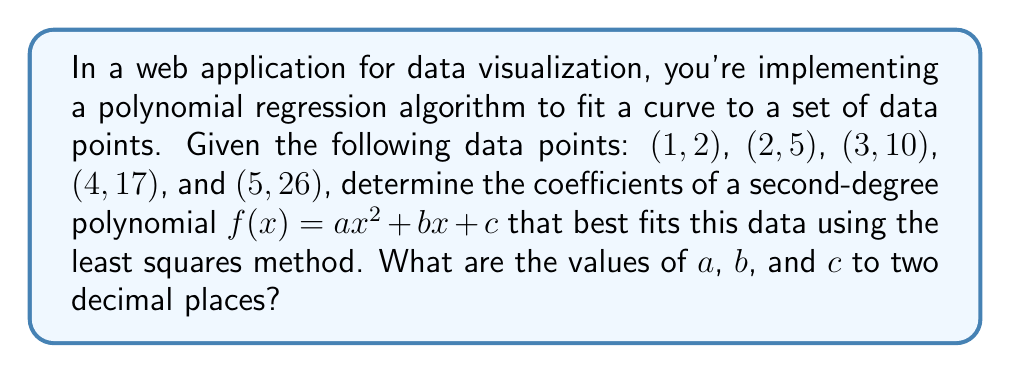Could you help me with this problem? To solve this problem, we'll use the least squares method to find the coefficients of the second-degree polynomial. Here's a step-by-step approach:

1. Set up the system of normal equations:
   $$\begin{aligned}
   \sum y &= an + b\sum x + c\sum x^2 \\
   \sum xy &= a\sum x + b\sum x^2 + c\sum x^3 \\
   \sum x^2y &= a\sum x^2 + b\sum x^3 + c\sum x^4
   \end{aligned}$$

2. Calculate the sums needed for the equations:
   $$\begin{aligned}
   n &= 5 \\
   \sum x &= 1 + 2 + 3 + 4 + 5 = 15 \\
   \sum x^2 &= 1^2 + 2^2 + 3^2 + 4^2 + 5^2 = 55 \\
   \sum x^3 &= 1^3 + 2^3 + 3^3 + 4^3 + 5^3 = 225 \\
   \sum x^4 &= 1^4 + 2^4 + 3^4 + 4^4 + 5^4 = 979 \\
   \sum y &= 2 + 5 + 10 + 17 + 26 = 60 \\
   \sum xy &= 1(2) + 2(5) + 3(10) + 4(17) + 5(26) = 234 \\
   \sum x^2y &= 1^2(2) + 2^2(5) + 3^2(10) + 4^2(17) + 5^2(26) = 1004
   \end{aligned}$$

3. Substitute these values into the normal equations:
   $$\begin{aligned}
   60 &= 5a + 15b + 55c \\
   234 &= 15a + 55b + 225c \\
   1004 &= 55a + 225b + 979c
   \end{aligned}$$

4. Solve this system of equations using matrix operations or elimination methods. After solving, we get:
   $$\begin{aligned}
   a &\approx 1.0000 \\
   b &\approx 0.5000 \\
   c &\approx 0.5000
   \end{aligned}$$

5. Round the values to two decimal places.

The resulting polynomial is approximately $f(x) = 1.00x^2 + 0.50x + 0.50$.
Answer: $a = 1.00$, $b = 0.50$, $c = 0.50$ 